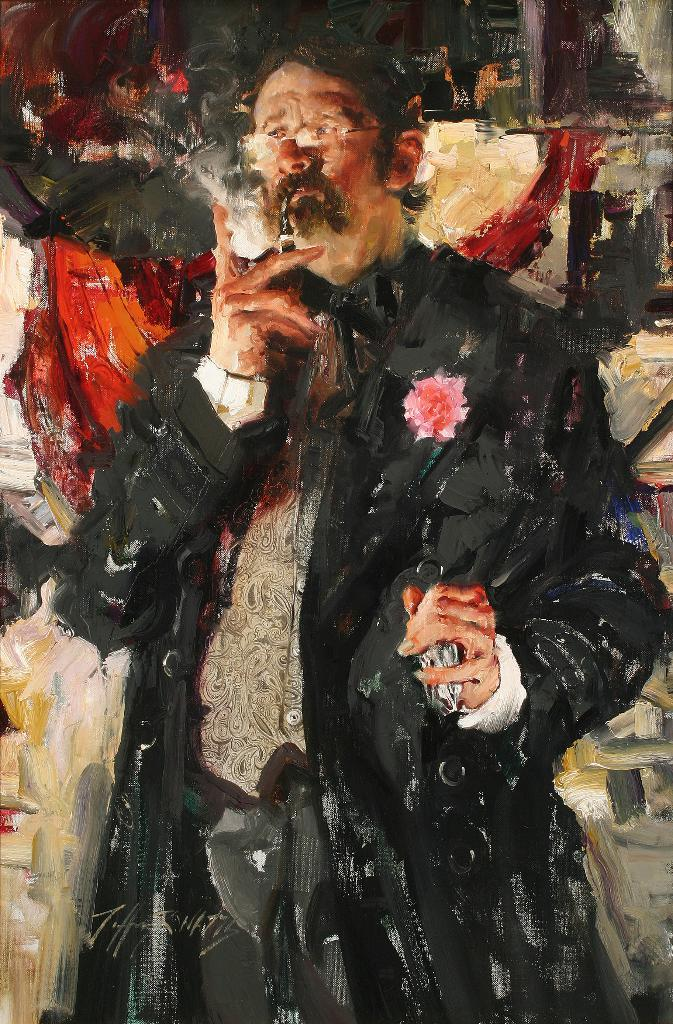What type of artwork is depicted in the image? The image is a painting. Can you describe the main subject of the painting? There is a man in the center of the painting. What is the man doing in the painting? The man is standing and holding a cigarette. What can be seen in the background of the painting? There is a wall in the background of the painting. What type of root can be seen growing from the man's head in the painting? There is no root growing from the man's head in the painting; he is simply holding a cigarette. Can you describe the mist surrounding the man in the painting? There is no mist present in the painting; it is a clear image of a man standing and holding a cigarette. 